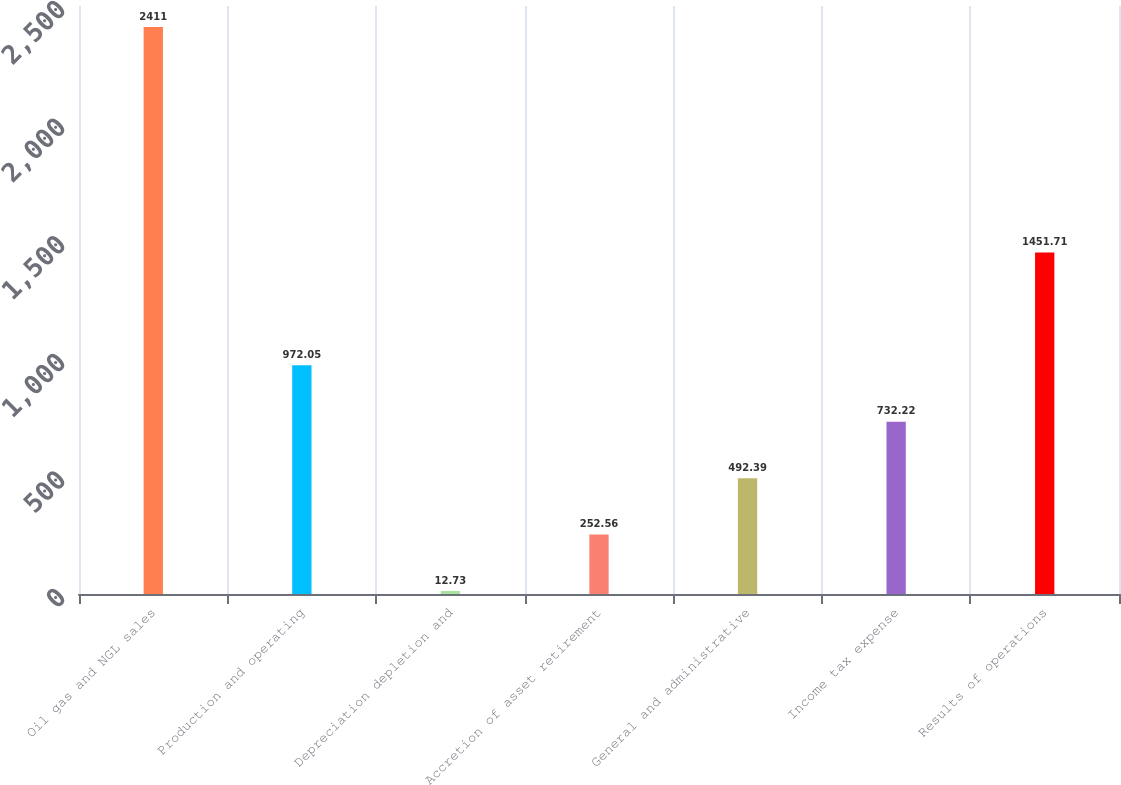Convert chart. <chart><loc_0><loc_0><loc_500><loc_500><bar_chart><fcel>Oil gas and NGL sales<fcel>Production and operating<fcel>Depreciation depletion and<fcel>Accretion of asset retirement<fcel>General and administrative<fcel>Income tax expense<fcel>Results of operations<nl><fcel>2411<fcel>972.05<fcel>12.73<fcel>252.56<fcel>492.39<fcel>732.22<fcel>1451.71<nl></chart> 